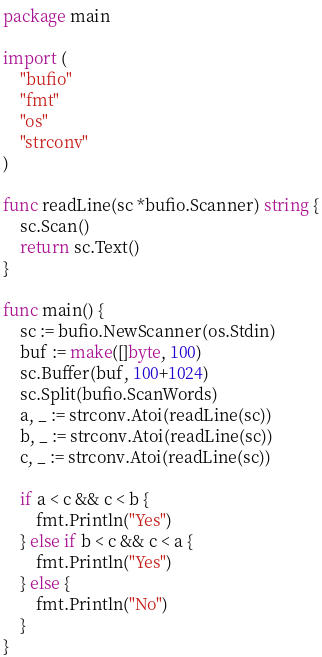<code> <loc_0><loc_0><loc_500><loc_500><_Go_>package main

import (
	"bufio"
	"fmt"
	"os"
	"strconv"
)

func readLine(sc *bufio.Scanner) string {
	sc.Scan()
	return sc.Text()
}

func main() {
	sc := bufio.NewScanner(os.Stdin)
	buf := make([]byte, 100)
	sc.Buffer(buf, 100+1024)
	sc.Split(bufio.ScanWords)
	a, _ := strconv.Atoi(readLine(sc))
	b, _ := strconv.Atoi(readLine(sc))
	c, _ := strconv.Atoi(readLine(sc))

	if a < c && c < b {
		fmt.Println("Yes")
	} else if b < c && c < a {
		fmt.Println("Yes")
	} else {
		fmt.Println("No")
	}
}
</code> 